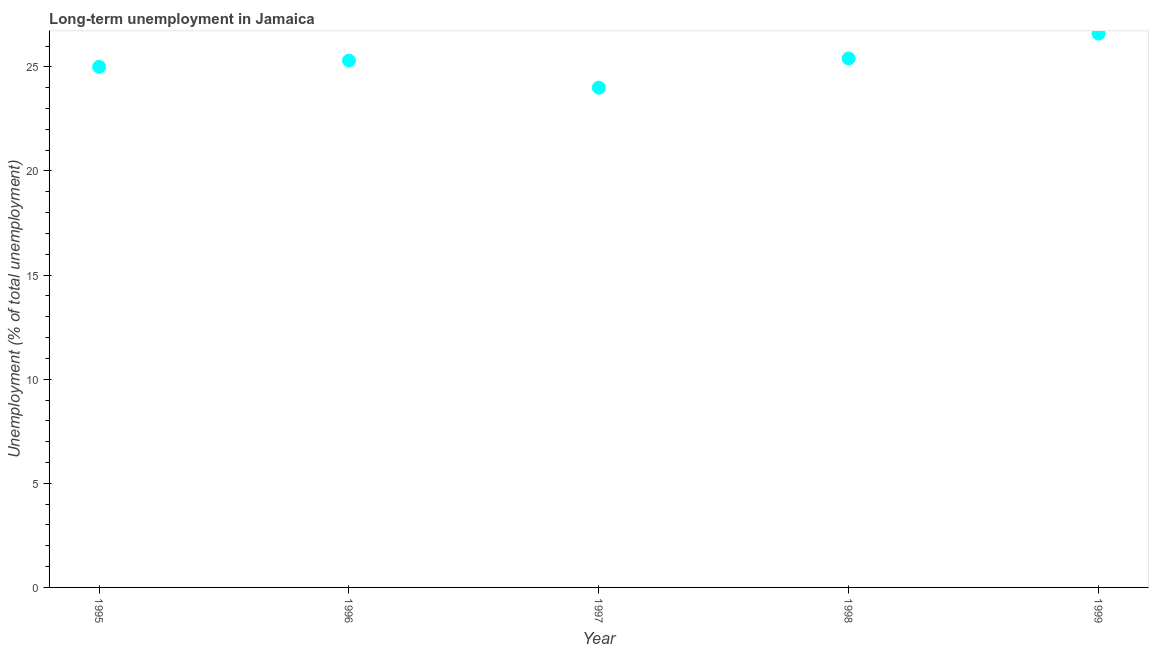What is the long-term unemployment in 1995?
Offer a very short reply. 25. Across all years, what is the maximum long-term unemployment?
Provide a succinct answer. 26.6. Across all years, what is the minimum long-term unemployment?
Offer a terse response. 24. What is the sum of the long-term unemployment?
Provide a short and direct response. 126.3. What is the difference between the long-term unemployment in 1997 and 1998?
Offer a terse response. -1.4. What is the average long-term unemployment per year?
Give a very brief answer. 25.26. What is the median long-term unemployment?
Provide a short and direct response. 25.3. In how many years, is the long-term unemployment greater than 17 %?
Provide a short and direct response. 5. What is the ratio of the long-term unemployment in 1995 to that in 1998?
Keep it short and to the point. 0.98. Is the difference between the long-term unemployment in 1995 and 1999 greater than the difference between any two years?
Give a very brief answer. No. What is the difference between the highest and the second highest long-term unemployment?
Your answer should be very brief. 1.2. Is the sum of the long-term unemployment in 1995 and 1996 greater than the maximum long-term unemployment across all years?
Your answer should be compact. Yes. What is the difference between the highest and the lowest long-term unemployment?
Provide a succinct answer. 2.6. In how many years, is the long-term unemployment greater than the average long-term unemployment taken over all years?
Offer a very short reply. 3. What is the difference between two consecutive major ticks on the Y-axis?
Your response must be concise. 5. Does the graph contain any zero values?
Ensure brevity in your answer.  No. What is the title of the graph?
Ensure brevity in your answer.  Long-term unemployment in Jamaica. What is the label or title of the X-axis?
Your answer should be compact. Year. What is the label or title of the Y-axis?
Ensure brevity in your answer.  Unemployment (% of total unemployment). What is the Unemployment (% of total unemployment) in 1995?
Your answer should be compact. 25. What is the Unemployment (% of total unemployment) in 1996?
Your response must be concise. 25.3. What is the Unemployment (% of total unemployment) in 1997?
Ensure brevity in your answer.  24. What is the Unemployment (% of total unemployment) in 1998?
Make the answer very short. 25.4. What is the Unemployment (% of total unemployment) in 1999?
Give a very brief answer. 26.6. What is the difference between the Unemployment (% of total unemployment) in 1995 and 1998?
Keep it short and to the point. -0.4. What is the difference between the Unemployment (% of total unemployment) in 1995 and 1999?
Offer a terse response. -1.6. What is the difference between the Unemployment (% of total unemployment) in 1996 and 1997?
Give a very brief answer. 1.3. What is the difference between the Unemployment (% of total unemployment) in 1996 and 1998?
Your answer should be very brief. -0.1. What is the difference between the Unemployment (% of total unemployment) in 1996 and 1999?
Ensure brevity in your answer.  -1.3. What is the difference between the Unemployment (% of total unemployment) in 1997 and 1999?
Provide a succinct answer. -2.6. What is the ratio of the Unemployment (% of total unemployment) in 1995 to that in 1996?
Provide a short and direct response. 0.99. What is the ratio of the Unemployment (% of total unemployment) in 1995 to that in 1997?
Give a very brief answer. 1.04. What is the ratio of the Unemployment (% of total unemployment) in 1995 to that in 1998?
Provide a short and direct response. 0.98. What is the ratio of the Unemployment (% of total unemployment) in 1996 to that in 1997?
Your response must be concise. 1.05. What is the ratio of the Unemployment (% of total unemployment) in 1996 to that in 1999?
Give a very brief answer. 0.95. What is the ratio of the Unemployment (% of total unemployment) in 1997 to that in 1998?
Your answer should be very brief. 0.94. What is the ratio of the Unemployment (% of total unemployment) in 1997 to that in 1999?
Your answer should be compact. 0.9. What is the ratio of the Unemployment (% of total unemployment) in 1998 to that in 1999?
Provide a succinct answer. 0.95. 